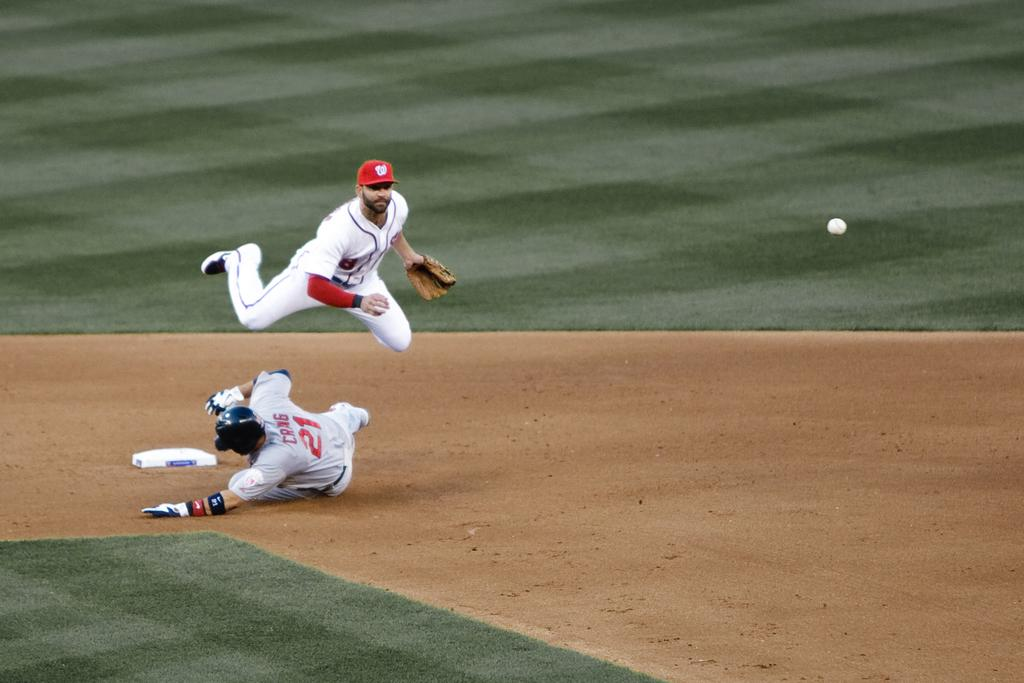<image>
Create a compact narrative representing the image presented. A baseball player is sliding and has the number 21 on the back. 